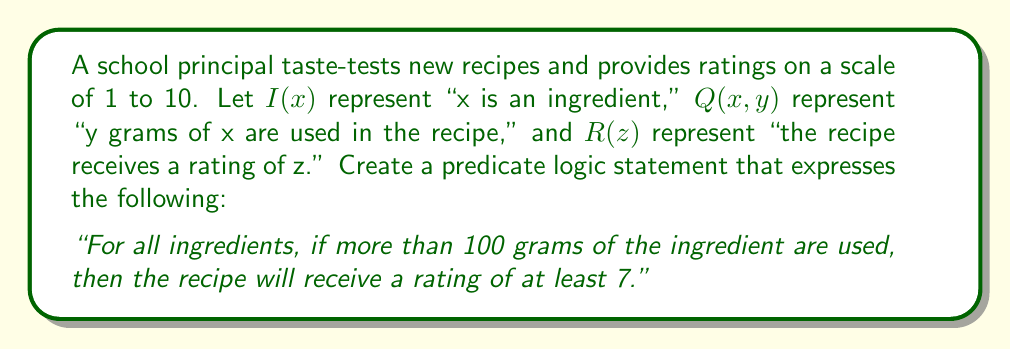Could you help me with this problem? To formalize this statement using predicate logic, we need to break it down into its components and use the appropriate quantifiers and logical connectives. Let's approach this step-by-step:

1. "For all ingredients" is represented by the universal quantifier $\forall x$.

2. "If more than 100 grams of the ingredient are used" can be expressed as $Q(x, y) \wedge (y > 100)$.

3. "The recipe will receive a rating of at least 7" can be written as $\exists z(R(z) \wedge (z \geq 7))$.

4. We need to connect these parts using implication ($\rightarrow$).

5. We also need to ensure that $x$ is indeed an ingredient, which is represented by $I(x)$.

Putting all these components together, we get:

$$\forall x [I(x) \rightarrow (\exists y(Q(x, y) \wedge (y > 100)) \rightarrow \exists z(R(z) \wedge (z \geq 7)))]$$

This statement reads as: "For all x, if x is an ingredient, then if there exists a y such that y grams of x are used and y is greater than 100, then there exists a z such that the recipe receives a rating of z and z is greater than or equal to 7."

This formalization accurately captures the relationship between ingredient quantities and taste ratings as described in the original statement.
Answer: $$\forall x [I(x) \rightarrow (\exists y(Q(x, y) \wedge (y > 100)) \rightarrow \exists z(R(z) \wedge (z \geq 7)))]$$ 